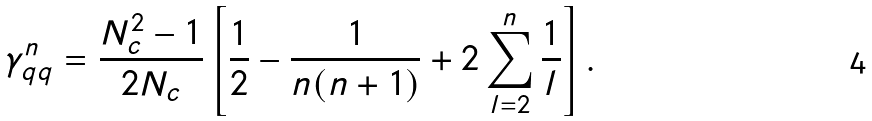Convert formula to latex. <formula><loc_0><loc_0><loc_500><loc_500>\gamma ^ { n } _ { q q } = \frac { N ^ { 2 } _ { c } - 1 } { 2 N _ { c } } \left [ \frac { 1 } { 2 } - \frac { 1 } { n ( n + 1 ) } + 2 \sum _ { l = 2 } ^ { n } \frac { 1 } { l } \right ] .</formula> 